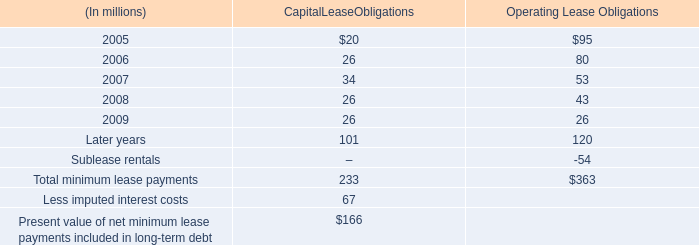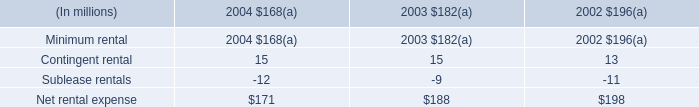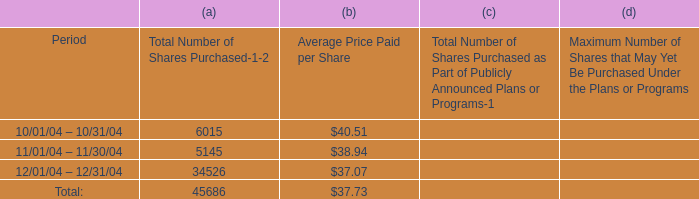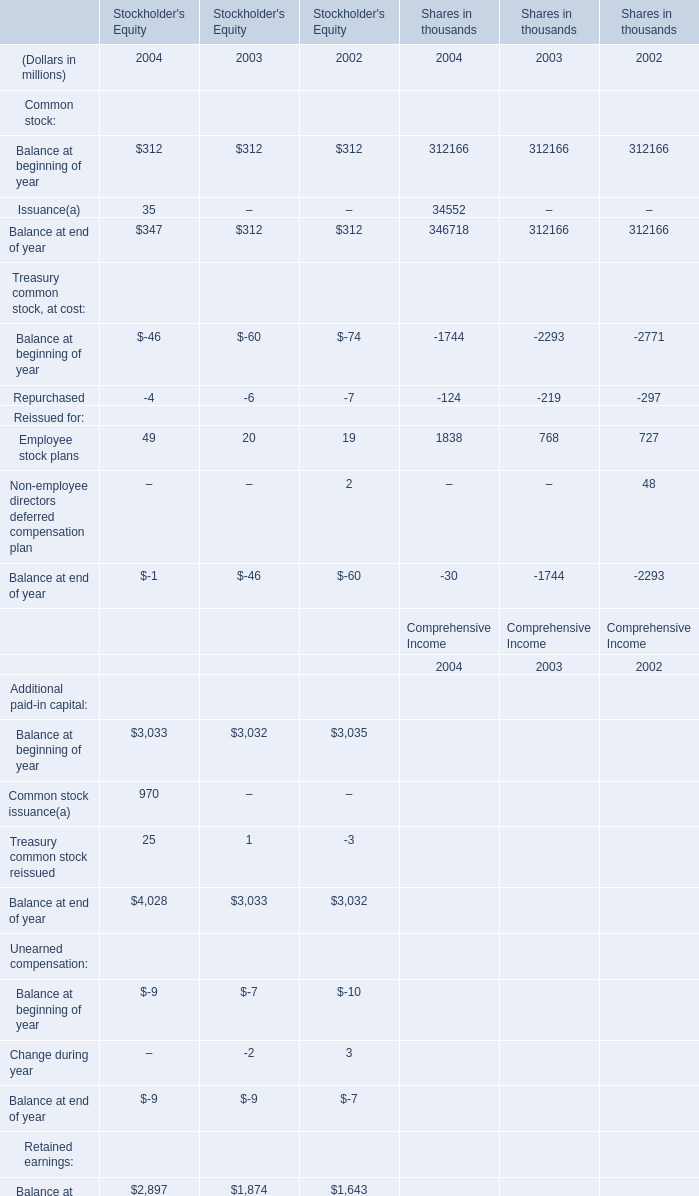What's the growth rate of Balance at end of year for for Common stock in Stockholder's Equity in 2004? 
Computations: ((347 - 312) / 312)
Answer: 0.11218. 